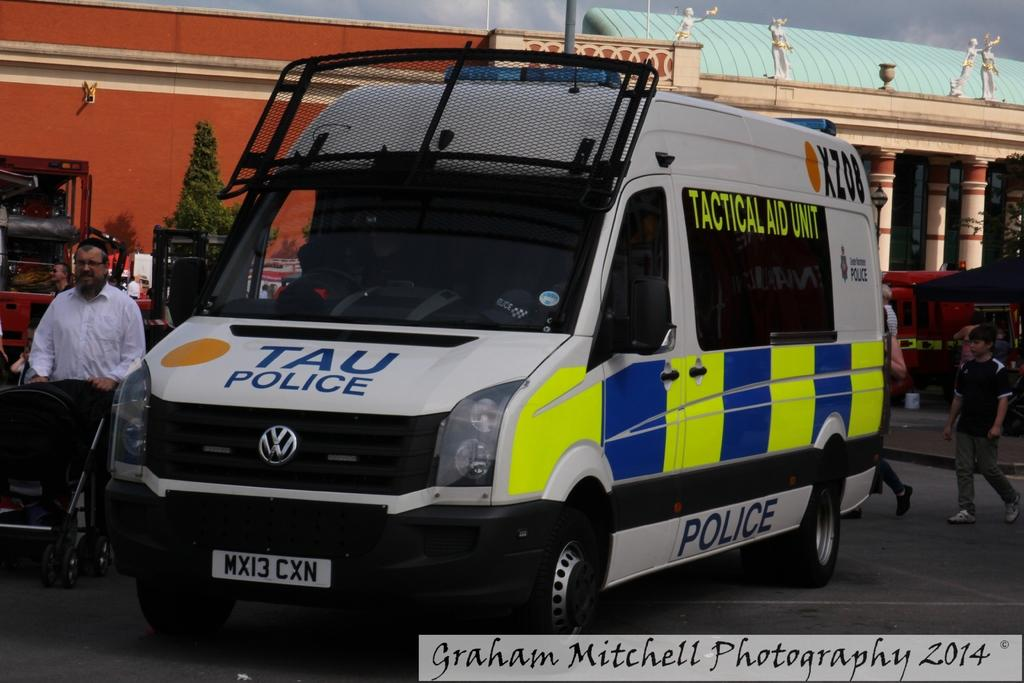<image>
Describe the image concisely. The Tau Police have a VW police van in its fleet. 